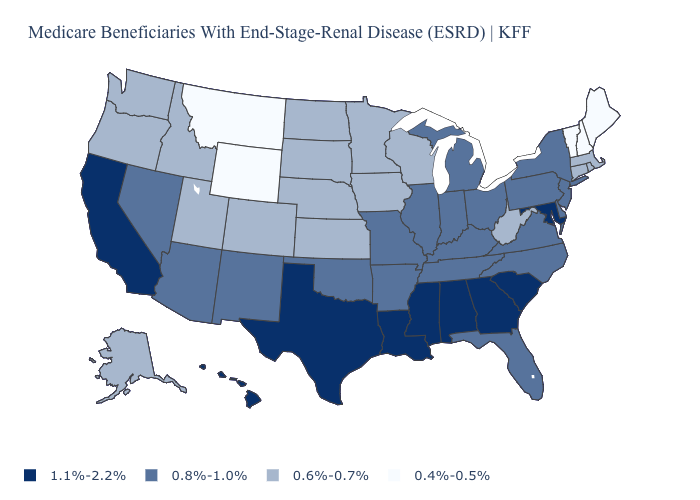What is the value of Mississippi?
Short answer required. 1.1%-2.2%. Name the states that have a value in the range 0.6%-0.7%?
Concise answer only. Alaska, Colorado, Connecticut, Idaho, Iowa, Kansas, Massachusetts, Minnesota, Nebraska, North Dakota, Oregon, Rhode Island, South Dakota, Utah, Washington, West Virginia, Wisconsin. Name the states that have a value in the range 0.4%-0.5%?
Concise answer only. Maine, Montana, New Hampshire, Vermont, Wyoming. Name the states that have a value in the range 0.6%-0.7%?
Quick response, please. Alaska, Colorado, Connecticut, Idaho, Iowa, Kansas, Massachusetts, Minnesota, Nebraska, North Dakota, Oregon, Rhode Island, South Dakota, Utah, Washington, West Virginia, Wisconsin. What is the value of Delaware?
Keep it brief. 0.8%-1.0%. Does the first symbol in the legend represent the smallest category?
Be succinct. No. Does Indiana have a lower value than Louisiana?
Answer briefly. Yes. What is the lowest value in states that border Maine?
Give a very brief answer. 0.4%-0.5%. What is the highest value in the West ?
Quick response, please. 1.1%-2.2%. Does the map have missing data?
Quick response, please. No. Name the states that have a value in the range 0.6%-0.7%?
Give a very brief answer. Alaska, Colorado, Connecticut, Idaho, Iowa, Kansas, Massachusetts, Minnesota, Nebraska, North Dakota, Oregon, Rhode Island, South Dakota, Utah, Washington, West Virginia, Wisconsin. Does Indiana have the lowest value in the MidWest?
Keep it brief. No. What is the value of Oklahoma?
Short answer required. 0.8%-1.0%. Name the states that have a value in the range 0.8%-1.0%?
Concise answer only. Arizona, Arkansas, Delaware, Florida, Illinois, Indiana, Kentucky, Michigan, Missouri, Nevada, New Jersey, New Mexico, New York, North Carolina, Ohio, Oklahoma, Pennsylvania, Tennessee, Virginia. Does the first symbol in the legend represent the smallest category?
Answer briefly. No. 